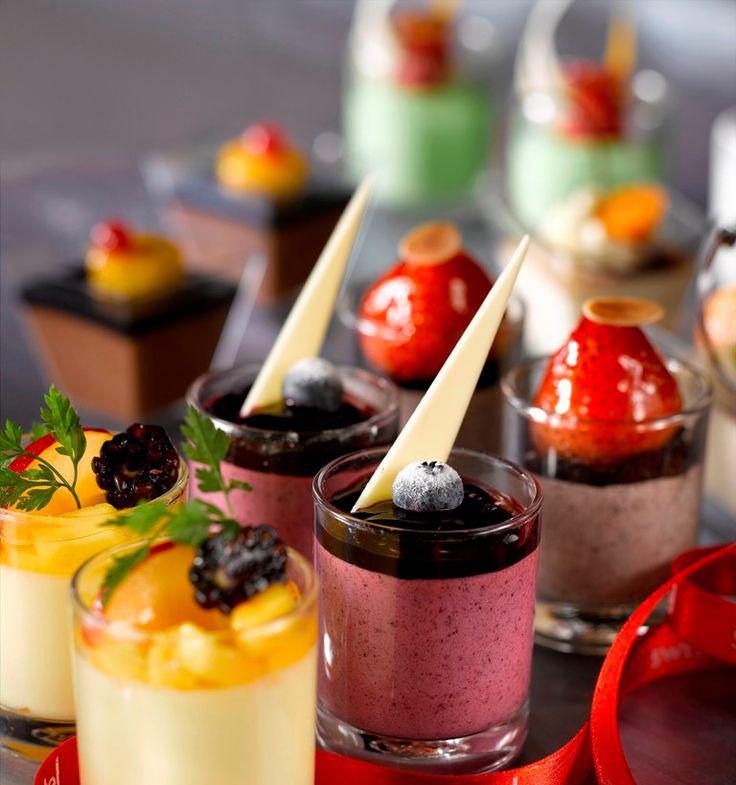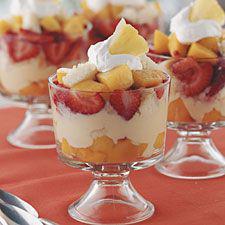The first image is the image on the left, the second image is the image on the right. For the images displayed, is the sentence "There are treats in the right image that are topped with cherries, but none in the left image." factually correct? Answer yes or no. No. 